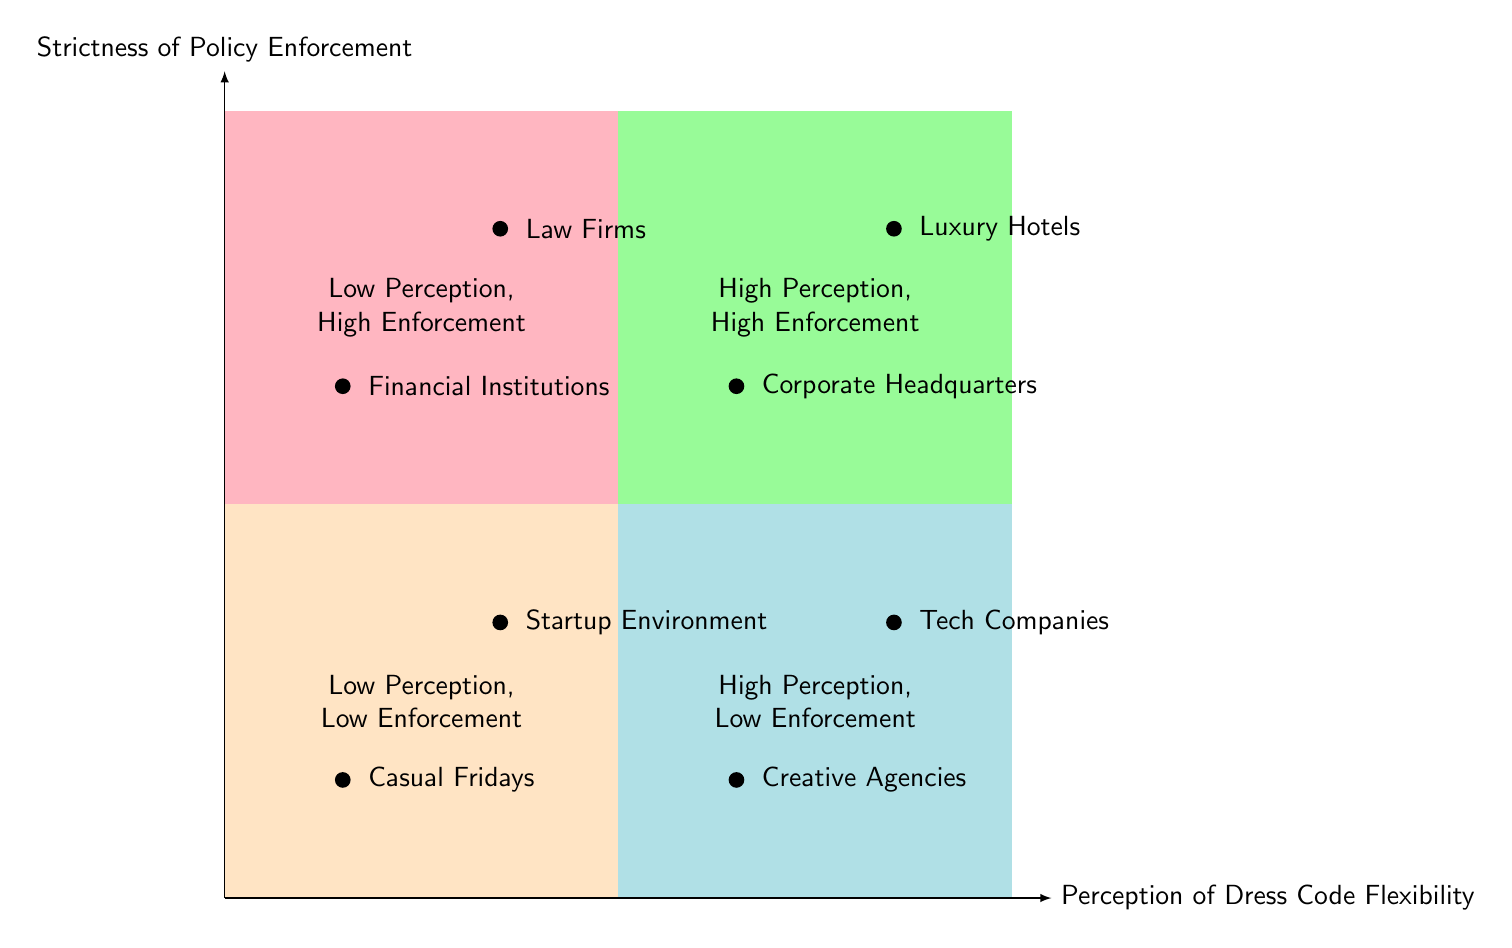What's in the quadrant "Low Perception, Low Enforcement"? The quadrant labeled "Low Perception, Low Enforcement" contains the elements "Casual Fridays" and "Startup Environment."
Answer: Casual Fridays, Startup Environment Which quadrant includes Financial Institutions? Financial Institutions is located in the quadrant named "Low Perception, High Enforcement."
Answer: Low Perception, High Enforcement How many elements are in the "High Perception, High Enforcement" quadrant? The "High Perception, High Enforcement" quadrant has two elements, "Corporate Headquarters" and "Luxury Hotels."
Answer: 2 What does the term "Strictness of Policy Enforcement" refer to? "Strictness of Policy Enforcement" refers to how rigorously dress code policies are applied in a workplace context, as depicted on the vertical axis of the chart.
Answer: Rigor of enforcement Which quadrant features elements of Creative Agencies? The "High Perception, Low Enforcement" quadrant features the elements of Creative Agencies.
Answer: High Perception, Low Enforcement Which two quadrants are characterized by a high perception of dress code flexibility? The two quadrants characterized by a high perception of dress code flexibility are "High Perception, Low Enforcement" and "High Perception, High Enforcement."
Answer: High Perception, Low Enforcement; High Perception, High Enforcement What is the relationship between Financial Institutions and Law Firms? Both Financial Institutions and Law Firms are located in the same quadrant, which indicates a "Low Perception, High Enforcement."
Answer: Same quadrant How does the diagram categorize a startup environment in terms of dress code? The diagram categorizes a startup environment in the "Low Perception, Low Enforcement" quadrant, suggesting a relaxed approach to dress codes.
Answer: Low Perception, Low Enforcement 